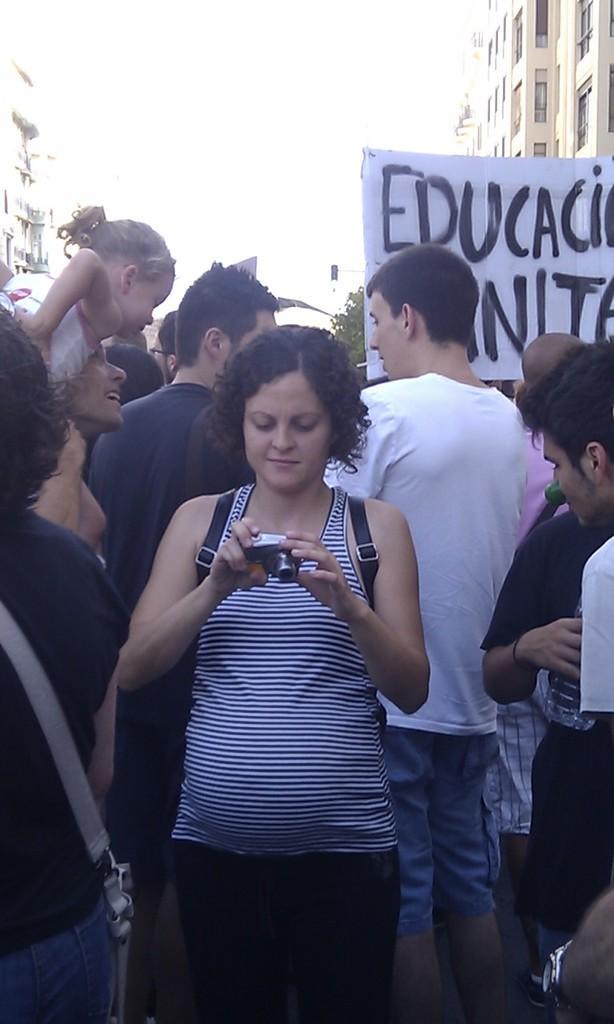Can you describe this image briefly? This image is taken outdoors. At the top of the image there is the sky. In the background there are two buildings. There is a tree. In the middle of the image many people are standing. A woman is holding a camera in her hands. On the right side of the image there is a banner with a text on it. 